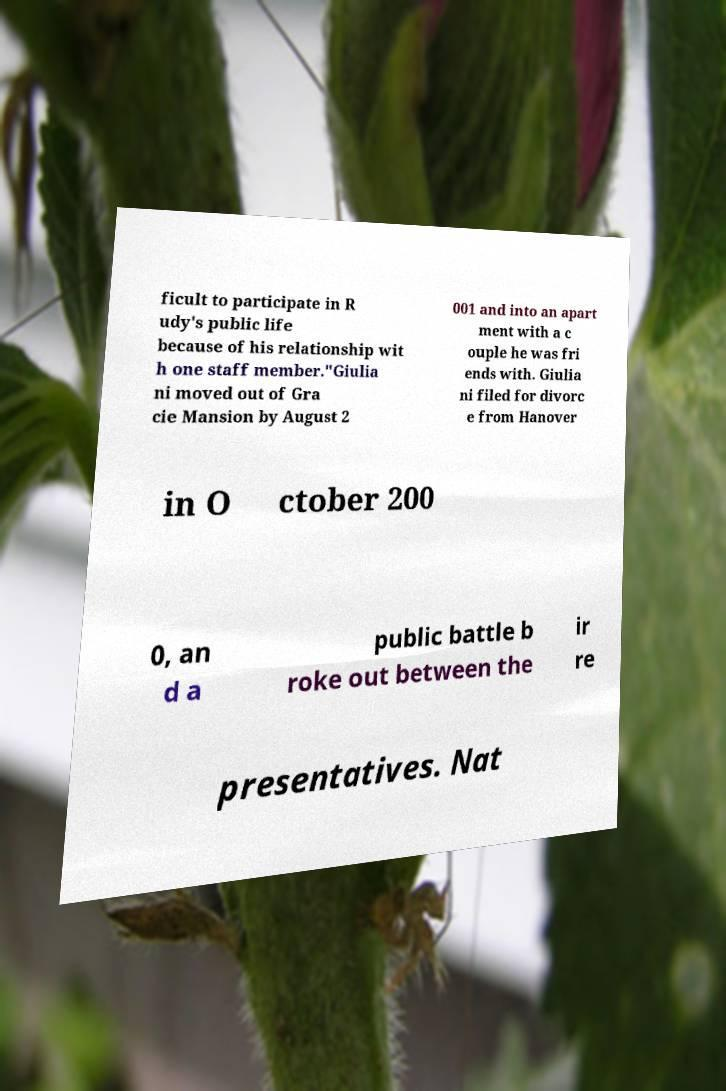I need the written content from this picture converted into text. Can you do that? ficult to participate in R udy's public life because of his relationship wit h one staff member."Giulia ni moved out of Gra cie Mansion by August 2 001 and into an apart ment with a c ouple he was fri ends with. Giulia ni filed for divorc e from Hanover in O ctober 200 0, an d a public battle b roke out between the ir re presentatives. Nat 